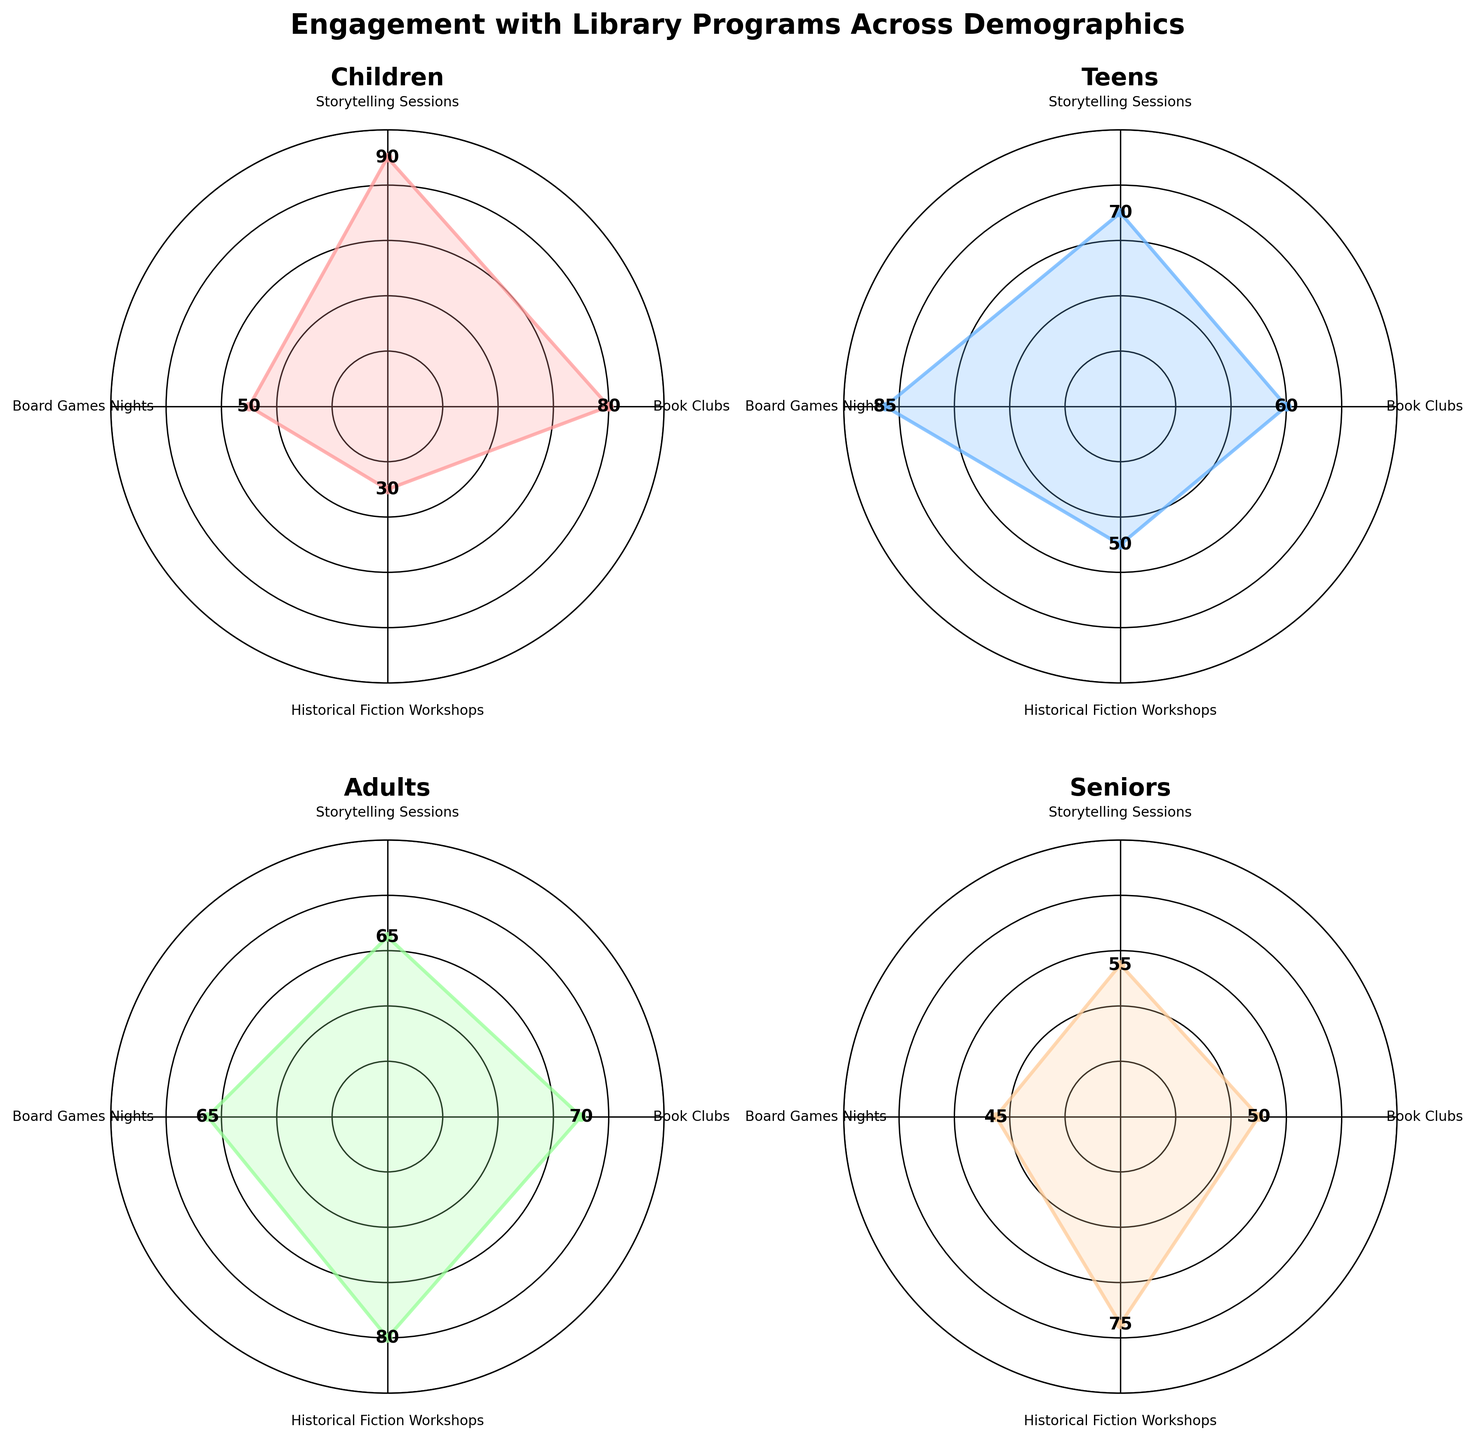What's the title of the figure? The title of the figure is positioned at the top and clearly states the overall theme it's depicting.
Answer: Engagement with Library Programs Across Demographics How many categories of library programs are represented in each radar chart subplot? Each subplot has axes that correspond to the categories of library programs. Counting the axes or labels will give you the number.
Answer: 4 Which demographic group has the highest engagement in Book Clubs? Look at the radar chart for each demographic and identify the one with the point furthest from the center in the "Book Clubs" axis.
Answer: Children Which demographic group has the lowest attendance in Storytelling Sessions? Compare the values on the "Storytelling Sessions" axis across all demographic subplots to find the lowest point.
Answer: Seniors How does the engagement in Board Games Nights compare between Teens and Adults? Compare the values on the "Board Games Nights" axis in the Teens and Adults subplots.
Answer: Teens have higher engagement What is the average engagement in Historical Fiction Workshops across all demographics? Sum the engagement values for Historical Fiction Workshops across all demographic groups and divide by the number of groups.
Answer: (30 + 50 + 80 + 75) / 4 = 58.75 Which program do Children engage in the most and the least? For Children, identify the highest and lowest points on the radar chart among the four axes.
Answer: Most: Storytelling Sessions, Least: Historical Fiction Workshops What is the combined engagement in Book Clubs and Board Games Nights for Seniors? Add the engagement values for Seniors in "Book Clubs" and "Board Games Nights" categories.
Answer: 50 + 45 = 95 In which category does the engagement difference between Adults and Seniors appear largest? For each category (axis), calculate the absolute difference in engagement values between Adults and Seniors and identify the largest number.
Answer: Historical Fiction Workshops How do the engagement patterns of Adults differ from those of Children in Storytelling Sessions and Board Games Nights? Compare the heights of the points on the "Storytelling Sessions" and "Board Games Nights" axes for Adults and Children, noting differences.
Answer: Adults have lower in Storytelling, higher in Board Games 